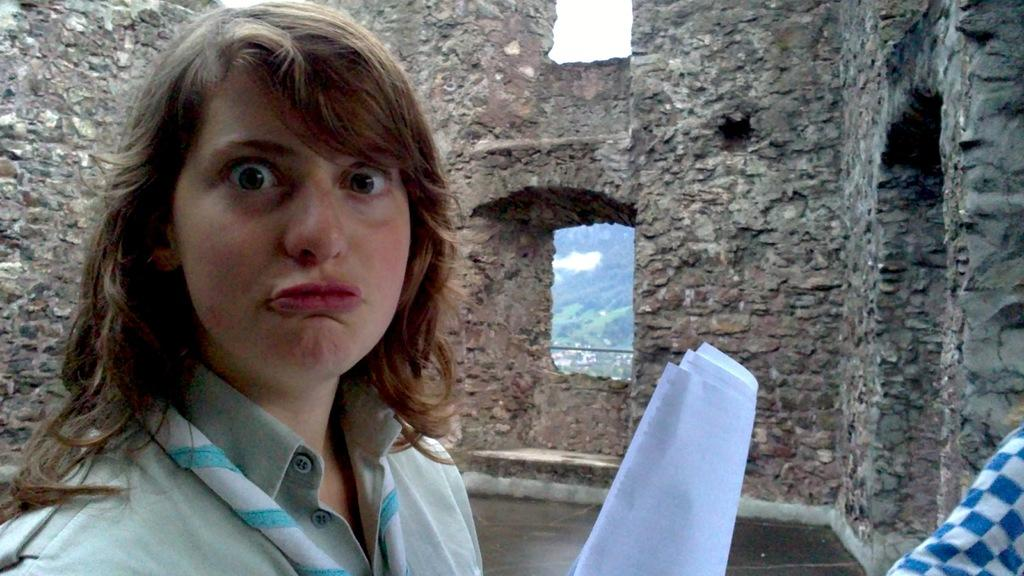Who is the main subject in the image? There is a lady in the image. What is the lady doing? The lady is making a facial expression. What is the lady wearing? The lady is wearing a green dress. What is the lady holding in her hand? The lady is holding papers in her hand. What type of detail can be seen on the lady's face in the image? There is no specific detail mentioned in the provided facts, so it is not possible to answer this question based on the given information. 